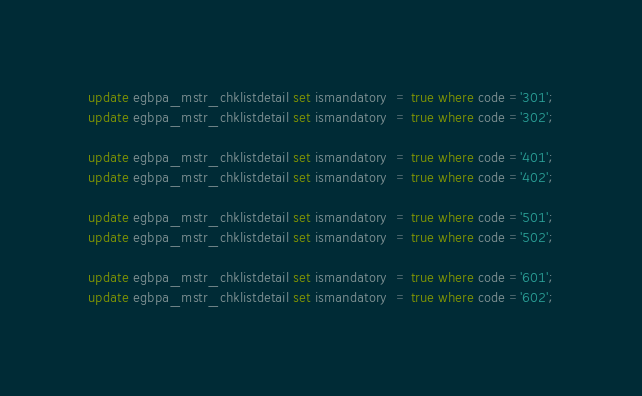Convert code to text. <code><loc_0><loc_0><loc_500><loc_500><_SQL_>
update egbpa_mstr_chklistdetail set ismandatory  = true where code ='301';
update egbpa_mstr_chklistdetail set ismandatory  = true where code ='302';

update egbpa_mstr_chklistdetail set ismandatory  = true where code ='401';
update egbpa_mstr_chklistdetail set ismandatory  = true where code ='402';

update egbpa_mstr_chklistdetail set ismandatory  = true where code ='501';
update egbpa_mstr_chklistdetail set ismandatory  = true where code ='502';

update egbpa_mstr_chklistdetail set ismandatory  = true where code ='601';
update egbpa_mstr_chklistdetail set ismandatory  = true where code ='602';
</code> 